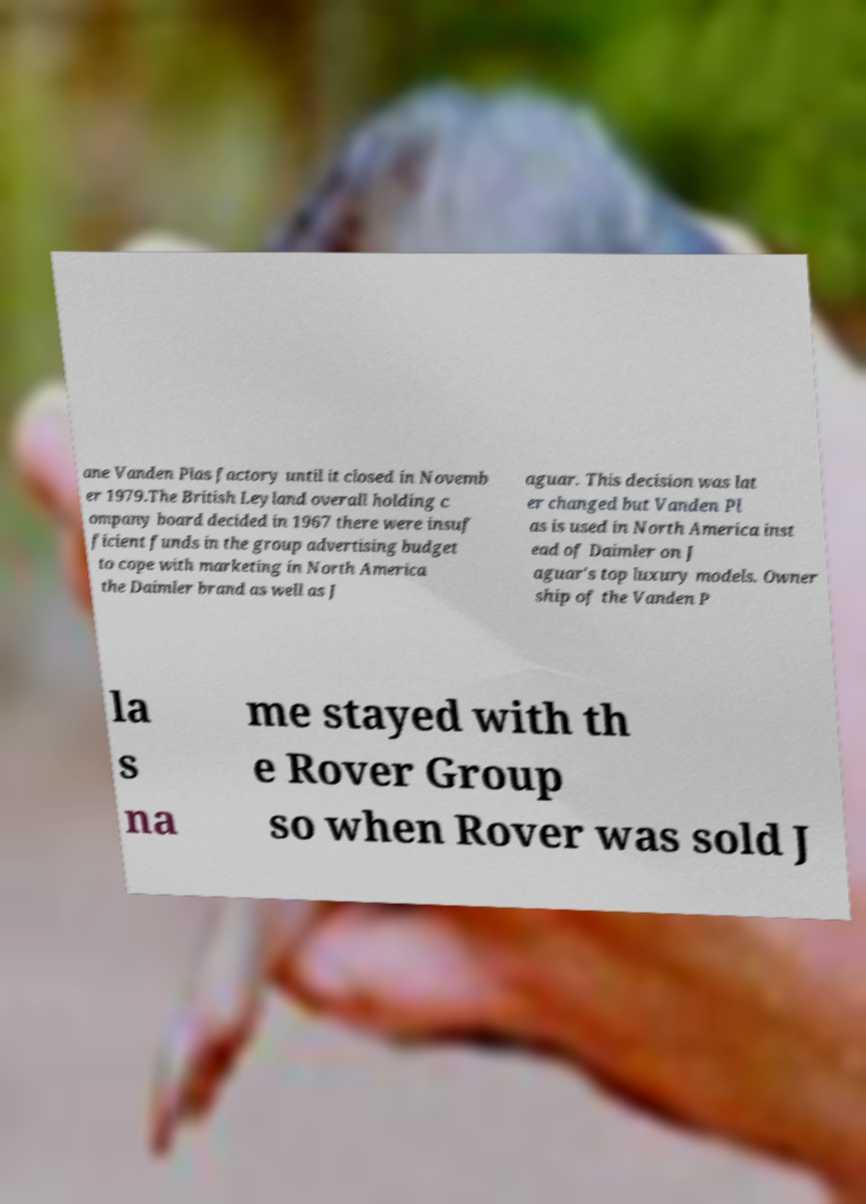Can you read and provide the text displayed in the image?This photo seems to have some interesting text. Can you extract and type it out for me? ane Vanden Plas factory until it closed in Novemb er 1979.The British Leyland overall holding c ompany board decided in 1967 there were insuf ficient funds in the group advertising budget to cope with marketing in North America the Daimler brand as well as J aguar. This decision was lat er changed but Vanden Pl as is used in North America inst ead of Daimler on J aguar's top luxury models. Owner ship of the Vanden P la s na me stayed with th e Rover Group so when Rover was sold J 